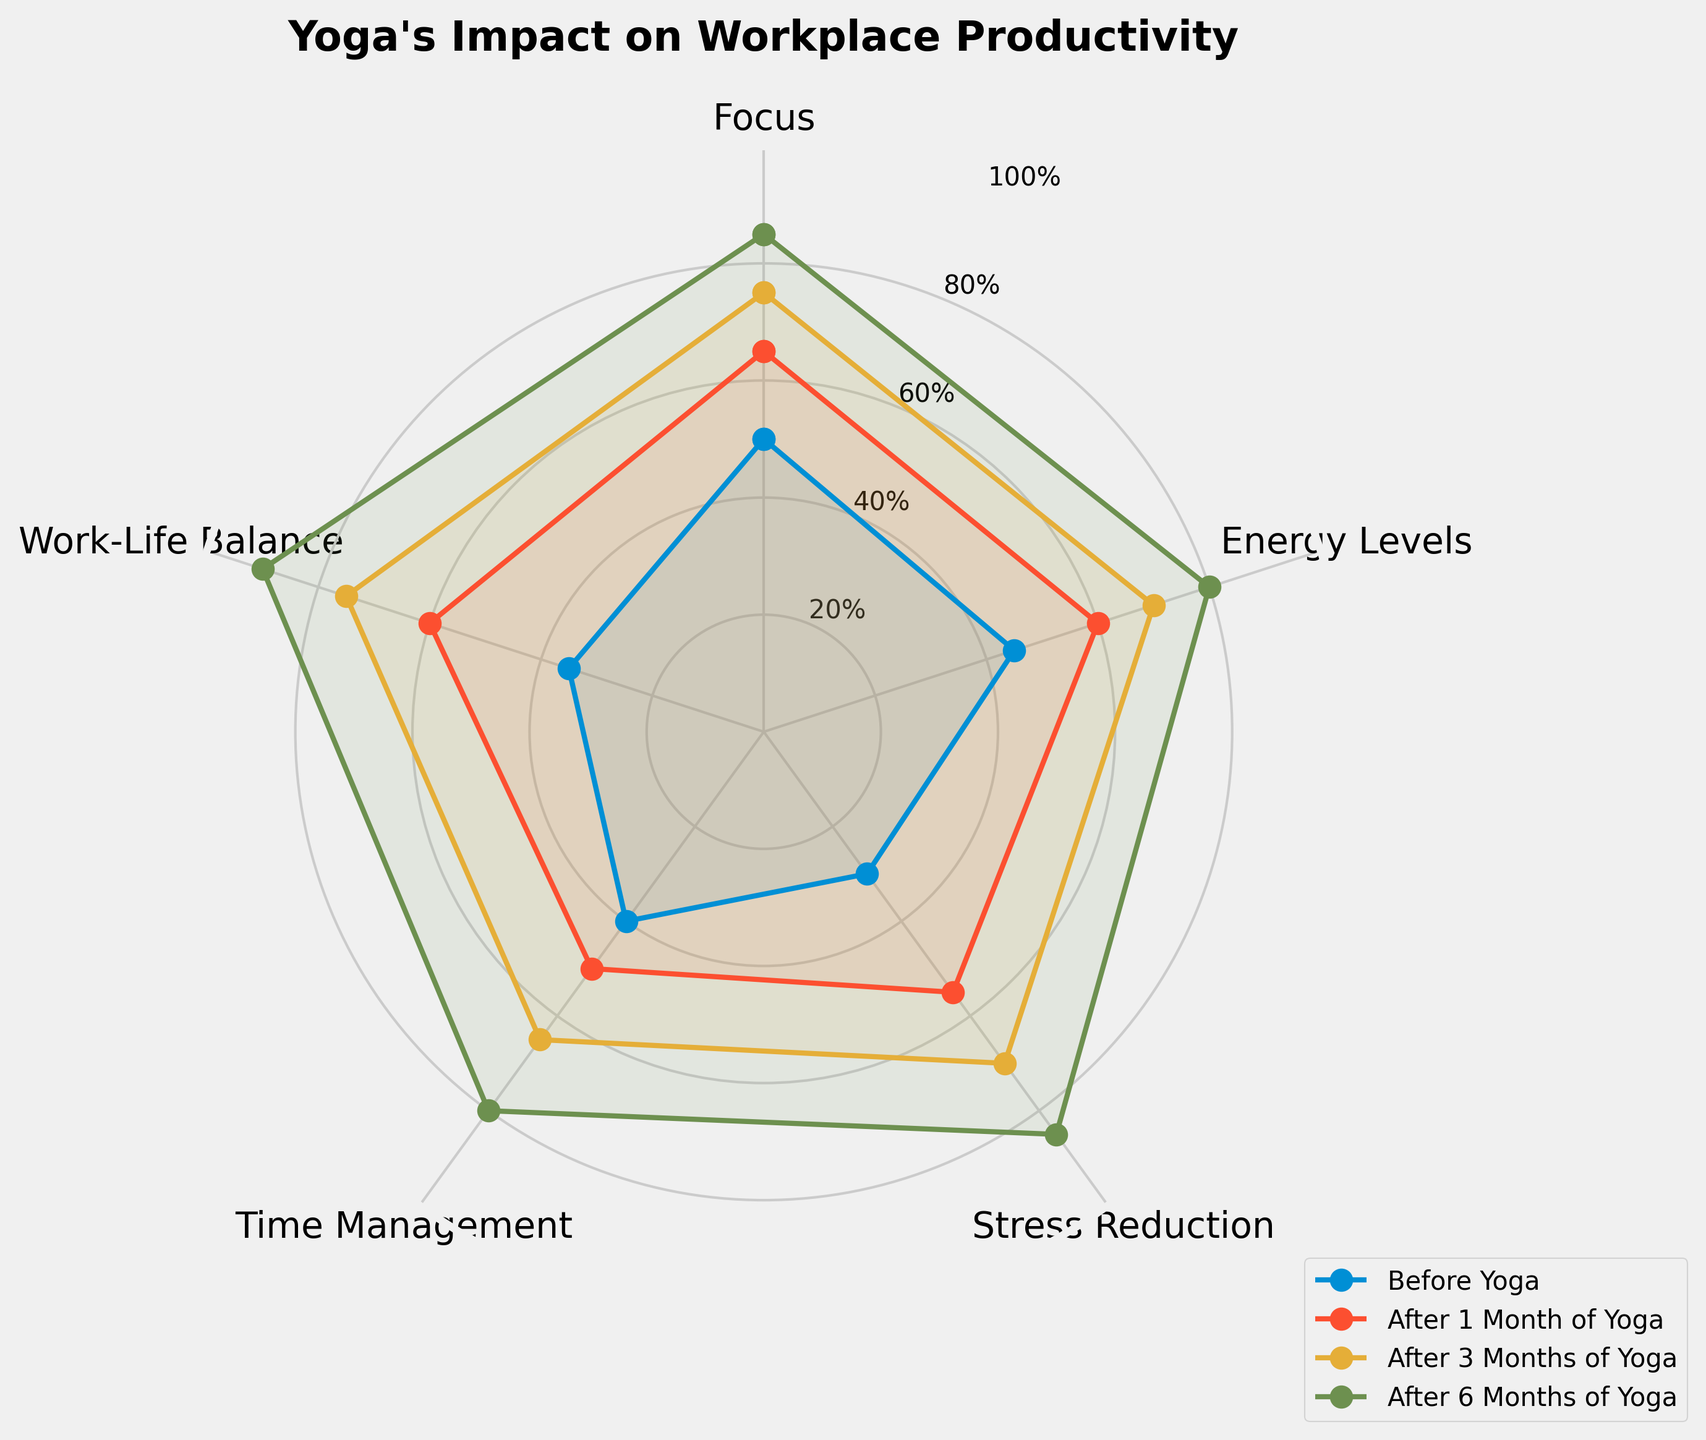What's the title of the radar chart? The title of the radar chart is a key label positioned at the top of the chart for easy reference. It summarizes the overall focus of the chart. Simply read the text at the top center of the chart.
Answer: Yoga's Impact on Workplace Productivity How many categories of productivity metrics are depicted in the radar chart? The chart displays these categories along the perimeter, separated by gridlines and labeled accordingly. Count each labeled section to determine the number of categories.
Answer: Five What is the value of 'Focus' before starting yoga? Look at the 'Before Yoga' line in the radar chart and find the point corresponding to the 'Focus' axis. The value at that point indicates the 'Focus' level before starting yoga.
Answer: 50 Which productivity metric shows the greatest improvement after 6 months of yoga compared to before yoga? Identify the values of each metric before yoga and after 6 months. Subtract the 'Before Yoga' value from the 'After 6 Months of Yoga' value for each metric. The metric with the largest positive difference indicates the greatest improvement.
Answer: Stress Reduction What is the average increase in 'Energy Levels' from 'Before Yoga' to 'After 6 Months of Yoga'? Calculate the difference between 'Before Yoga' and 'After 6 Months of Yoga' values for 'Energy Levels'. Divide this difference by the number of categories (5).
Answer: 35 Which metric demonstrates consistently increasing values across all time points? For each metric, observe the trend from 'Before Yoga', 'After 1 Month of Yoga', 'After 3 Months of Yoga', to 'After 6 Months of Yoga'. Identify the metric that consistently shows higher values at each successive time point.
Answer: All metrics How does the 'Work-Life Balance' after 1 month of yoga compare to other categories at the same time point? Locate the 'After 1 Month of Yoga' values for 'Work-Life Balance' and other categories. Compare these values to determine the relative position of 'Work-Life Balance'.
Answer: Higher than 'Focus', 'Energy Levels', 'Stress Reduction', and 'Time Management' Which category saw the least improvement after 3 months of yoga? Determine the improvement for each category by comparing values 'Before Yoga' and 'After 3 Months of Yoga'. The smallest positive difference indicates the least improvement.
Answer: Time Management What is the total increase in 'Time Management' values from 'Before Yoga' to 'After 6 Months of Yoga'? Calculate the difference between 'Before Yoga' and 'After 6 Months of Yoga' for 'Time Management'. Sum these differences if needed for a total increase across the time span.
Answer: 40 How does 'Focus' after 1 month of yoga compare to 'Energy Levels' after 3 months of yoga? Locate the values of 'Focus' and 'Energy Levels' at the specified time points. Compare the values directly.
Answer: Lower than 'Energy Levels' 